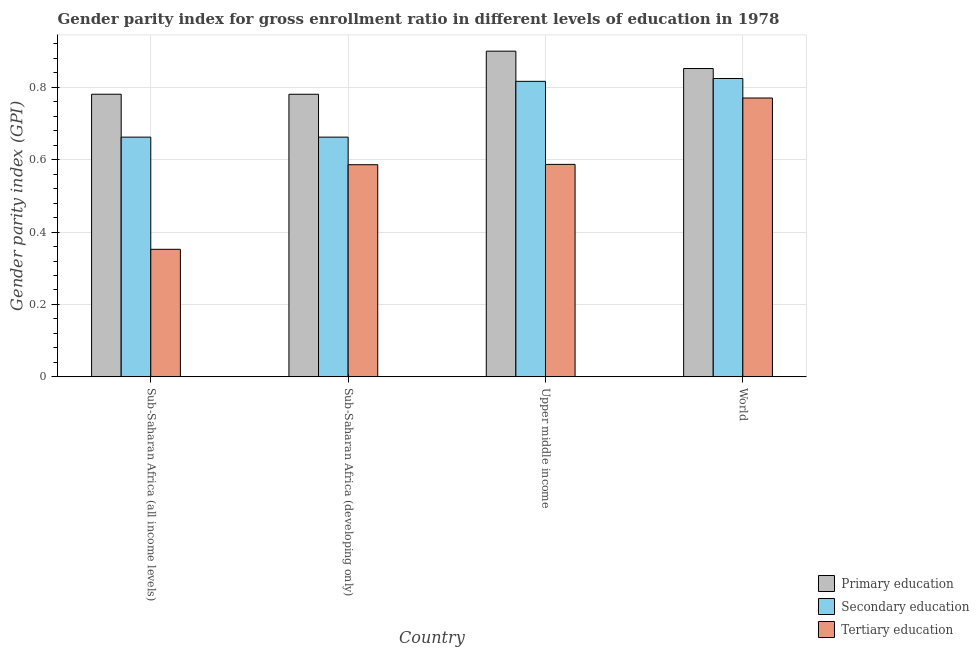Are the number of bars on each tick of the X-axis equal?
Offer a terse response. Yes. In how many cases, is the number of bars for a given country not equal to the number of legend labels?
Your answer should be very brief. 0. What is the gender parity index in secondary education in Sub-Saharan Africa (all income levels)?
Your answer should be compact. 0.66. Across all countries, what is the maximum gender parity index in tertiary education?
Offer a very short reply. 0.77. Across all countries, what is the minimum gender parity index in secondary education?
Provide a succinct answer. 0.66. In which country was the gender parity index in secondary education maximum?
Make the answer very short. World. In which country was the gender parity index in tertiary education minimum?
Your answer should be compact. Sub-Saharan Africa (all income levels). What is the total gender parity index in primary education in the graph?
Your response must be concise. 3.31. What is the difference between the gender parity index in secondary education in Sub-Saharan Africa (all income levels) and that in Upper middle income?
Give a very brief answer. -0.15. What is the difference between the gender parity index in primary education in Sub-Saharan Africa (developing only) and the gender parity index in secondary education in World?
Ensure brevity in your answer.  -0.04. What is the average gender parity index in tertiary education per country?
Provide a short and direct response. 0.57. What is the difference between the gender parity index in tertiary education and gender parity index in primary education in Upper middle income?
Keep it short and to the point. -0.31. What is the ratio of the gender parity index in tertiary education in Sub-Saharan Africa (all income levels) to that in World?
Make the answer very short. 0.46. What is the difference between the highest and the second highest gender parity index in primary education?
Give a very brief answer. 0.05. What is the difference between the highest and the lowest gender parity index in secondary education?
Make the answer very short. 0.16. Is the sum of the gender parity index in tertiary education in Sub-Saharan Africa (developing only) and Upper middle income greater than the maximum gender parity index in secondary education across all countries?
Give a very brief answer. Yes. What does the 2nd bar from the left in Sub-Saharan Africa (developing only) represents?
Provide a short and direct response. Secondary education. What does the 1st bar from the right in Sub-Saharan Africa (all income levels) represents?
Keep it short and to the point. Tertiary education. How many bars are there?
Make the answer very short. 12. Are all the bars in the graph horizontal?
Your answer should be compact. No. Are the values on the major ticks of Y-axis written in scientific E-notation?
Your response must be concise. No. Does the graph contain any zero values?
Provide a succinct answer. No. What is the title of the graph?
Make the answer very short. Gender parity index for gross enrollment ratio in different levels of education in 1978. What is the label or title of the Y-axis?
Your answer should be compact. Gender parity index (GPI). What is the Gender parity index (GPI) of Primary education in Sub-Saharan Africa (all income levels)?
Keep it short and to the point. 0.78. What is the Gender parity index (GPI) in Secondary education in Sub-Saharan Africa (all income levels)?
Offer a very short reply. 0.66. What is the Gender parity index (GPI) of Tertiary education in Sub-Saharan Africa (all income levels)?
Offer a terse response. 0.35. What is the Gender parity index (GPI) of Primary education in Sub-Saharan Africa (developing only)?
Ensure brevity in your answer.  0.78. What is the Gender parity index (GPI) of Secondary education in Sub-Saharan Africa (developing only)?
Your answer should be very brief. 0.66. What is the Gender parity index (GPI) in Tertiary education in Sub-Saharan Africa (developing only)?
Provide a succinct answer. 0.59. What is the Gender parity index (GPI) in Primary education in Upper middle income?
Provide a short and direct response. 0.9. What is the Gender parity index (GPI) of Secondary education in Upper middle income?
Provide a short and direct response. 0.82. What is the Gender parity index (GPI) of Tertiary education in Upper middle income?
Your response must be concise. 0.59. What is the Gender parity index (GPI) in Primary education in World?
Your answer should be very brief. 0.85. What is the Gender parity index (GPI) in Secondary education in World?
Provide a short and direct response. 0.82. What is the Gender parity index (GPI) of Tertiary education in World?
Keep it short and to the point. 0.77. Across all countries, what is the maximum Gender parity index (GPI) in Primary education?
Your response must be concise. 0.9. Across all countries, what is the maximum Gender parity index (GPI) in Secondary education?
Provide a short and direct response. 0.82. Across all countries, what is the maximum Gender parity index (GPI) of Tertiary education?
Offer a very short reply. 0.77. Across all countries, what is the minimum Gender parity index (GPI) in Primary education?
Offer a terse response. 0.78. Across all countries, what is the minimum Gender parity index (GPI) in Secondary education?
Your answer should be very brief. 0.66. Across all countries, what is the minimum Gender parity index (GPI) of Tertiary education?
Ensure brevity in your answer.  0.35. What is the total Gender parity index (GPI) in Primary education in the graph?
Your answer should be compact. 3.31. What is the total Gender parity index (GPI) in Secondary education in the graph?
Your answer should be compact. 2.96. What is the total Gender parity index (GPI) in Tertiary education in the graph?
Your response must be concise. 2.3. What is the difference between the Gender parity index (GPI) of Secondary education in Sub-Saharan Africa (all income levels) and that in Sub-Saharan Africa (developing only)?
Give a very brief answer. -0. What is the difference between the Gender parity index (GPI) of Tertiary education in Sub-Saharan Africa (all income levels) and that in Sub-Saharan Africa (developing only)?
Ensure brevity in your answer.  -0.23. What is the difference between the Gender parity index (GPI) of Primary education in Sub-Saharan Africa (all income levels) and that in Upper middle income?
Ensure brevity in your answer.  -0.12. What is the difference between the Gender parity index (GPI) in Secondary education in Sub-Saharan Africa (all income levels) and that in Upper middle income?
Offer a very short reply. -0.15. What is the difference between the Gender parity index (GPI) of Tertiary education in Sub-Saharan Africa (all income levels) and that in Upper middle income?
Give a very brief answer. -0.23. What is the difference between the Gender parity index (GPI) of Primary education in Sub-Saharan Africa (all income levels) and that in World?
Provide a succinct answer. -0.07. What is the difference between the Gender parity index (GPI) in Secondary education in Sub-Saharan Africa (all income levels) and that in World?
Keep it short and to the point. -0.16. What is the difference between the Gender parity index (GPI) in Tertiary education in Sub-Saharan Africa (all income levels) and that in World?
Offer a terse response. -0.42. What is the difference between the Gender parity index (GPI) in Primary education in Sub-Saharan Africa (developing only) and that in Upper middle income?
Your response must be concise. -0.12. What is the difference between the Gender parity index (GPI) in Secondary education in Sub-Saharan Africa (developing only) and that in Upper middle income?
Give a very brief answer. -0.15. What is the difference between the Gender parity index (GPI) in Tertiary education in Sub-Saharan Africa (developing only) and that in Upper middle income?
Give a very brief answer. -0. What is the difference between the Gender parity index (GPI) of Primary education in Sub-Saharan Africa (developing only) and that in World?
Offer a terse response. -0.07. What is the difference between the Gender parity index (GPI) in Secondary education in Sub-Saharan Africa (developing only) and that in World?
Ensure brevity in your answer.  -0.16. What is the difference between the Gender parity index (GPI) of Tertiary education in Sub-Saharan Africa (developing only) and that in World?
Make the answer very short. -0.18. What is the difference between the Gender parity index (GPI) in Primary education in Upper middle income and that in World?
Provide a succinct answer. 0.05. What is the difference between the Gender parity index (GPI) in Secondary education in Upper middle income and that in World?
Your response must be concise. -0.01. What is the difference between the Gender parity index (GPI) of Tertiary education in Upper middle income and that in World?
Your response must be concise. -0.18. What is the difference between the Gender parity index (GPI) of Primary education in Sub-Saharan Africa (all income levels) and the Gender parity index (GPI) of Secondary education in Sub-Saharan Africa (developing only)?
Provide a succinct answer. 0.12. What is the difference between the Gender parity index (GPI) in Primary education in Sub-Saharan Africa (all income levels) and the Gender parity index (GPI) in Tertiary education in Sub-Saharan Africa (developing only)?
Offer a terse response. 0.19. What is the difference between the Gender parity index (GPI) of Secondary education in Sub-Saharan Africa (all income levels) and the Gender parity index (GPI) of Tertiary education in Sub-Saharan Africa (developing only)?
Ensure brevity in your answer.  0.08. What is the difference between the Gender parity index (GPI) of Primary education in Sub-Saharan Africa (all income levels) and the Gender parity index (GPI) of Secondary education in Upper middle income?
Your answer should be compact. -0.04. What is the difference between the Gender parity index (GPI) of Primary education in Sub-Saharan Africa (all income levels) and the Gender parity index (GPI) of Tertiary education in Upper middle income?
Keep it short and to the point. 0.19. What is the difference between the Gender parity index (GPI) of Secondary education in Sub-Saharan Africa (all income levels) and the Gender parity index (GPI) of Tertiary education in Upper middle income?
Provide a short and direct response. 0.08. What is the difference between the Gender parity index (GPI) of Primary education in Sub-Saharan Africa (all income levels) and the Gender parity index (GPI) of Secondary education in World?
Make the answer very short. -0.04. What is the difference between the Gender parity index (GPI) of Primary education in Sub-Saharan Africa (all income levels) and the Gender parity index (GPI) of Tertiary education in World?
Your answer should be very brief. 0.01. What is the difference between the Gender parity index (GPI) in Secondary education in Sub-Saharan Africa (all income levels) and the Gender parity index (GPI) in Tertiary education in World?
Ensure brevity in your answer.  -0.11. What is the difference between the Gender parity index (GPI) of Primary education in Sub-Saharan Africa (developing only) and the Gender parity index (GPI) of Secondary education in Upper middle income?
Ensure brevity in your answer.  -0.04. What is the difference between the Gender parity index (GPI) in Primary education in Sub-Saharan Africa (developing only) and the Gender parity index (GPI) in Tertiary education in Upper middle income?
Keep it short and to the point. 0.19. What is the difference between the Gender parity index (GPI) in Secondary education in Sub-Saharan Africa (developing only) and the Gender parity index (GPI) in Tertiary education in Upper middle income?
Provide a succinct answer. 0.08. What is the difference between the Gender parity index (GPI) of Primary education in Sub-Saharan Africa (developing only) and the Gender parity index (GPI) of Secondary education in World?
Your response must be concise. -0.04. What is the difference between the Gender parity index (GPI) of Primary education in Sub-Saharan Africa (developing only) and the Gender parity index (GPI) of Tertiary education in World?
Give a very brief answer. 0.01. What is the difference between the Gender parity index (GPI) in Secondary education in Sub-Saharan Africa (developing only) and the Gender parity index (GPI) in Tertiary education in World?
Offer a terse response. -0.11. What is the difference between the Gender parity index (GPI) in Primary education in Upper middle income and the Gender parity index (GPI) in Secondary education in World?
Your response must be concise. 0.08. What is the difference between the Gender parity index (GPI) in Primary education in Upper middle income and the Gender parity index (GPI) in Tertiary education in World?
Keep it short and to the point. 0.13. What is the difference between the Gender parity index (GPI) of Secondary education in Upper middle income and the Gender parity index (GPI) of Tertiary education in World?
Your answer should be very brief. 0.05. What is the average Gender parity index (GPI) of Primary education per country?
Provide a short and direct response. 0.83. What is the average Gender parity index (GPI) in Secondary education per country?
Your answer should be compact. 0.74. What is the average Gender parity index (GPI) in Tertiary education per country?
Provide a succinct answer. 0.57. What is the difference between the Gender parity index (GPI) of Primary education and Gender parity index (GPI) of Secondary education in Sub-Saharan Africa (all income levels)?
Offer a very short reply. 0.12. What is the difference between the Gender parity index (GPI) in Primary education and Gender parity index (GPI) in Tertiary education in Sub-Saharan Africa (all income levels)?
Provide a succinct answer. 0.43. What is the difference between the Gender parity index (GPI) in Secondary education and Gender parity index (GPI) in Tertiary education in Sub-Saharan Africa (all income levels)?
Provide a short and direct response. 0.31. What is the difference between the Gender parity index (GPI) in Primary education and Gender parity index (GPI) in Secondary education in Sub-Saharan Africa (developing only)?
Your answer should be very brief. 0.12. What is the difference between the Gender parity index (GPI) of Primary education and Gender parity index (GPI) of Tertiary education in Sub-Saharan Africa (developing only)?
Offer a very short reply. 0.19. What is the difference between the Gender parity index (GPI) of Secondary education and Gender parity index (GPI) of Tertiary education in Sub-Saharan Africa (developing only)?
Give a very brief answer. 0.08. What is the difference between the Gender parity index (GPI) in Primary education and Gender parity index (GPI) in Secondary education in Upper middle income?
Offer a terse response. 0.08. What is the difference between the Gender parity index (GPI) of Primary education and Gender parity index (GPI) of Tertiary education in Upper middle income?
Make the answer very short. 0.31. What is the difference between the Gender parity index (GPI) in Secondary education and Gender parity index (GPI) in Tertiary education in Upper middle income?
Provide a succinct answer. 0.23. What is the difference between the Gender parity index (GPI) of Primary education and Gender parity index (GPI) of Secondary education in World?
Offer a very short reply. 0.03. What is the difference between the Gender parity index (GPI) of Primary education and Gender parity index (GPI) of Tertiary education in World?
Ensure brevity in your answer.  0.08. What is the difference between the Gender parity index (GPI) in Secondary education and Gender parity index (GPI) in Tertiary education in World?
Provide a succinct answer. 0.05. What is the ratio of the Gender parity index (GPI) of Primary education in Sub-Saharan Africa (all income levels) to that in Sub-Saharan Africa (developing only)?
Keep it short and to the point. 1. What is the ratio of the Gender parity index (GPI) of Secondary education in Sub-Saharan Africa (all income levels) to that in Sub-Saharan Africa (developing only)?
Offer a very short reply. 1. What is the ratio of the Gender parity index (GPI) in Tertiary education in Sub-Saharan Africa (all income levels) to that in Sub-Saharan Africa (developing only)?
Ensure brevity in your answer.  0.6. What is the ratio of the Gender parity index (GPI) in Primary education in Sub-Saharan Africa (all income levels) to that in Upper middle income?
Ensure brevity in your answer.  0.87. What is the ratio of the Gender parity index (GPI) of Secondary education in Sub-Saharan Africa (all income levels) to that in Upper middle income?
Give a very brief answer. 0.81. What is the ratio of the Gender parity index (GPI) of Tertiary education in Sub-Saharan Africa (all income levels) to that in Upper middle income?
Make the answer very short. 0.6. What is the ratio of the Gender parity index (GPI) of Primary education in Sub-Saharan Africa (all income levels) to that in World?
Provide a short and direct response. 0.92. What is the ratio of the Gender parity index (GPI) of Secondary education in Sub-Saharan Africa (all income levels) to that in World?
Give a very brief answer. 0.8. What is the ratio of the Gender parity index (GPI) in Tertiary education in Sub-Saharan Africa (all income levels) to that in World?
Provide a short and direct response. 0.46. What is the ratio of the Gender parity index (GPI) of Primary education in Sub-Saharan Africa (developing only) to that in Upper middle income?
Provide a succinct answer. 0.87. What is the ratio of the Gender parity index (GPI) in Secondary education in Sub-Saharan Africa (developing only) to that in Upper middle income?
Make the answer very short. 0.81. What is the ratio of the Gender parity index (GPI) of Tertiary education in Sub-Saharan Africa (developing only) to that in Upper middle income?
Provide a short and direct response. 1. What is the ratio of the Gender parity index (GPI) in Primary education in Sub-Saharan Africa (developing only) to that in World?
Your answer should be very brief. 0.92. What is the ratio of the Gender parity index (GPI) in Secondary education in Sub-Saharan Africa (developing only) to that in World?
Your response must be concise. 0.8. What is the ratio of the Gender parity index (GPI) in Tertiary education in Sub-Saharan Africa (developing only) to that in World?
Ensure brevity in your answer.  0.76. What is the ratio of the Gender parity index (GPI) of Primary education in Upper middle income to that in World?
Your answer should be very brief. 1.06. What is the ratio of the Gender parity index (GPI) of Tertiary education in Upper middle income to that in World?
Offer a very short reply. 0.76. What is the difference between the highest and the second highest Gender parity index (GPI) of Primary education?
Keep it short and to the point. 0.05. What is the difference between the highest and the second highest Gender parity index (GPI) of Secondary education?
Your answer should be very brief. 0.01. What is the difference between the highest and the second highest Gender parity index (GPI) in Tertiary education?
Ensure brevity in your answer.  0.18. What is the difference between the highest and the lowest Gender parity index (GPI) in Primary education?
Offer a very short reply. 0.12. What is the difference between the highest and the lowest Gender parity index (GPI) of Secondary education?
Give a very brief answer. 0.16. What is the difference between the highest and the lowest Gender parity index (GPI) in Tertiary education?
Offer a terse response. 0.42. 